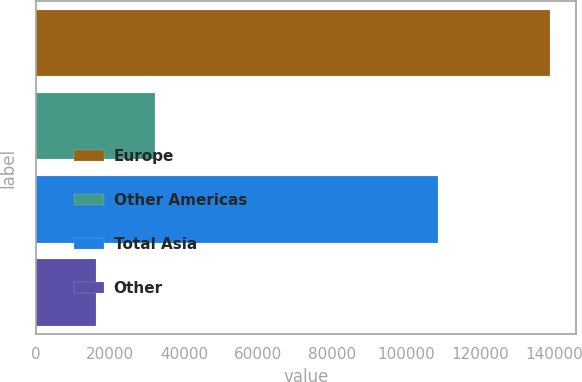<chart> <loc_0><loc_0><loc_500><loc_500><bar_chart><fcel>Europe<fcel>Other Americas<fcel>Total Asia<fcel>Other<nl><fcel>138829<fcel>32072<fcel>108556<fcel>16176<nl></chart> 